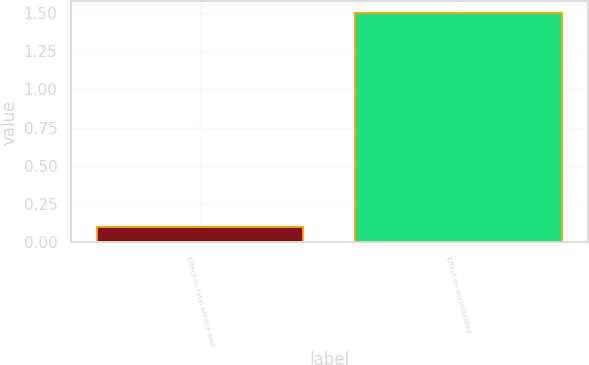<chart> <loc_0><loc_0><loc_500><loc_500><bar_chart><fcel>Effect on total service and<fcel>Effect on accumulated<nl><fcel>0.1<fcel>1.5<nl></chart> 